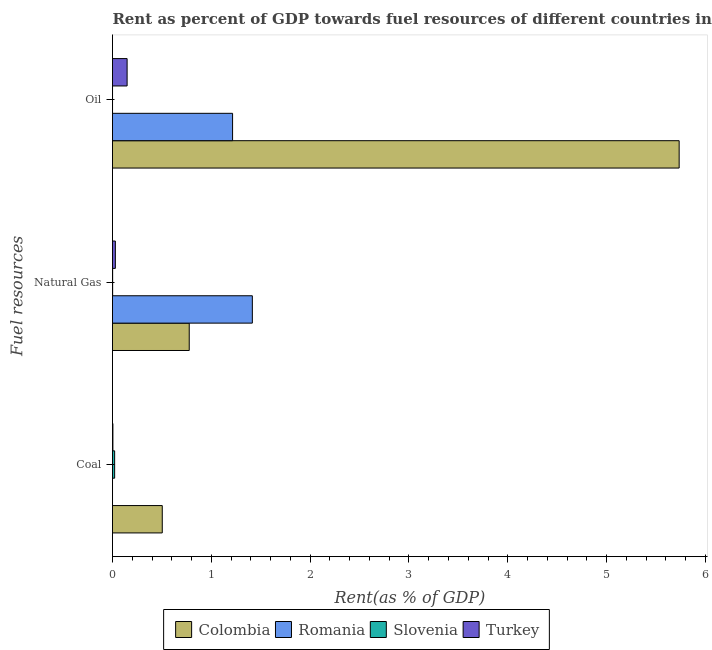How many different coloured bars are there?
Ensure brevity in your answer.  4. How many groups of bars are there?
Your answer should be compact. 3. Are the number of bars per tick equal to the number of legend labels?
Provide a succinct answer. Yes. What is the label of the 1st group of bars from the top?
Your answer should be very brief. Oil. What is the rent towards natural gas in Colombia?
Offer a terse response. 0.78. Across all countries, what is the maximum rent towards natural gas?
Your answer should be compact. 1.42. Across all countries, what is the minimum rent towards coal?
Give a very brief answer. 9.89979329873995e-5. In which country was the rent towards natural gas minimum?
Offer a very short reply. Slovenia. What is the total rent towards natural gas in the graph?
Make the answer very short. 2.22. What is the difference between the rent towards oil in Slovenia and that in Colombia?
Provide a short and direct response. -5.73. What is the difference between the rent towards oil in Slovenia and the rent towards natural gas in Romania?
Keep it short and to the point. -1.41. What is the average rent towards coal per country?
Provide a short and direct response. 0.13. What is the difference between the rent towards coal and rent towards oil in Colombia?
Your response must be concise. -5.23. What is the ratio of the rent towards oil in Turkey to that in Slovenia?
Keep it short and to the point. 640.72. What is the difference between the highest and the second highest rent towards oil?
Keep it short and to the point. 4.52. What is the difference between the highest and the lowest rent towards natural gas?
Provide a succinct answer. 1.41. In how many countries, is the rent towards coal greater than the average rent towards coal taken over all countries?
Your answer should be compact. 1. Is the sum of the rent towards coal in Turkey and Colombia greater than the maximum rent towards oil across all countries?
Provide a succinct answer. No. What does the 4th bar from the top in Coal represents?
Provide a succinct answer. Colombia. How many bars are there?
Offer a terse response. 12. How many countries are there in the graph?
Provide a short and direct response. 4. Are the values on the major ticks of X-axis written in scientific E-notation?
Provide a short and direct response. No. Where does the legend appear in the graph?
Your answer should be very brief. Bottom center. How are the legend labels stacked?
Provide a succinct answer. Horizontal. What is the title of the graph?
Make the answer very short. Rent as percent of GDP towards fuel resources of different countries in 2007. Does "St. Kitts and Nevis" appear as one of the legend labels in the graph?
Provide a short and direct response. No. What is the label or title of the X-axis?
Offer a very short reply. Rent(as % of GDP). What is the label or title of the Y-axis?
Offer a very short reply. Fuel resources. What is the Rent(as % of GDP) in Colombia in Coal?
Make the answer very short. 0.5. What is the Rent(as % of GDP) in Romania in Coal?
Your answer should be very brief. 9.89979329873995e-5. What is the Rent(as % of GDP) in Slovenia in Coal?
Offer a very short reply. 0.02. What is the Rent(as % of GDP) of Turkey in Coal?
Your answer should be compact. 0. What is the Rent(as % of GDP) of Colombia in Natural Gas?
Your response must be concise. 0.78. What is the Rent(as % of GDP) of Romania in Natural Gas?
Keep it short and to the point. 1.42. What is the Rent(as % of GDP) of Slovenia in Natural Gas?
Provide a succinct answer. 0. What is the Rent(as % of GDP) in Turkey in Natural Gas?
Offer a very short reply. 0.03. What is the Rent(as % of GDP) in Colombia in Oil?
Provide a succinct answer. 5.73. What is the Rent(as % of GDP) of Romania in Oil?
Give a very brief answer. 1.22. What is the Rent(as % of GDP) in Slovenia in Oil?
Offer a very short reply. 0. What is the Rent(as % of GDP) in Turkey in Oil?
Make the answer very short. 0.15. Across all Fuel resources, what is the maximum Rent(as % of GDP) in Colombia?
Provide a short and direct response. 5.73. Across all Fuel resources, what is the maximum Rent(as % of GDP) of Romania?
Give a very brief answer. 1.42. Across all Fuel resources, what is the maximum Rent(as % of GDP) in Slovenia?
Offer a terse response. 0.02. Across all Fuel resources, what is the maximum Rent(as % of GDP) in Turkey?
Provide a short and direct response. 0.15. Across all Fuel resources, what is the minimum Rent(as % of GDP) in Colombia?
Offer a terse response. 0.5. Across all Fuel resources, what is the minimum Rent(as % of GDP) of Romania?
Offer a very short reply. 9.89979329873995e-5. Across all Fuel resources, what is the minimum Rent(as % of GDP) of Slovenia?
Offer a very short reply. 0. Across all Fuel resources, what is the minimum Rent(as % of GDP) of Turkey?
Provide a short and direct response. 0. What is the total Rent(as % of GDP) in Colombia in the graph?
Your response must be concise. 7.01. What is the total Rent(as % of GDP) of Romania in the graph?
Provide a short and direct response. 2.63. What is the total Rent(as % of GDP) of Slovenia in the graph?
Offer a terse response. 0.02. What is the total Rent(as % of GDP) of Turkey in the graph?
Provide a succinct answer. 0.18. What is the difference between the Rent(as % of GDP) in Colombia in Coal and that in Natural Gas?
Make the answer very short. -0.27. What is the difference between the Rent(as % of GDP) of Romania in Coal and that in Natural Gas?
Your response must be concise. -1.42. What is the difference between the Rent(as % of GDP) in Slovenia in Coal and that in Natural Gas?
Your response must be concise. 0.02. What is the difference between the Rent(as % of GDP) of Turkey in Coal and that in Natural Gas?
Make the answer very short. -0.02. What is the difference between the Rent(as % of GDP) in Colombia in Coal and that in Oil?
Offer a terse response. -5.23. What is the difference between the Rent(as % of GDP) of Romania in Coal and that in Oil?
Your answer should be compact. -1.22. What is the difference between the Rent(as % of GDP) in Slovenia in Coal and that in Oil?
Ensure brevity in your answer.  0.02. What is the difference between the Rent(as % of GDP) in Turkey in Coal and that in Oil?
Ensure brevity in your answer.  -0.14. What is the difference between the Rent(as % of GDP) of Colombia in Natural Gas and that in Oil?
Give a very brief answer. -4.96. What is the difference between the Rent(as % of GDP) in Romania in Natural Gas and that in Oil?
Offer a terse response. 0.2. What is the difference between the Rent(as % of GDP) in Slovenia in Natural Gas and that in Oil?
Offer a terse response. 0. What is the difference between the Rent(as % of GDP) in Turkey in Natural Gas and that in Oil?
Provide a succinct answer. -0.12. What is the difference between the Rent(as % of GDP) in Colombia in Coal and the Rent(as % of GDP) in Romania in Natural Gas?
Provide a short and direct response. -0.91. What is the difference between the Rent(as % of GDP) in Colombia in Coal and the Rent(as % of GDP) in Slovenia in Natural Gas?
Your answer should be very brief. 0.5. What is the difference between the Rent(as % of GDP) of Colombia in Coal and the Rent(as % of GDP) of Turkey in Natural Gas?
Offer a very short reply. 0.47. What is the difference between the Rent(as % of GDP) of Romania in Coal and the Rent(as % of GDP) of Slovenia in Natural Gas?
Offer a very short reply. -0. What is the difference between the Rent(as % of GDP) in Romania in Coal and the Rent(as % of GDP) in Turkey in Natural Gas?
Make the answer very short. -0.03. What is the difference between the Rent(as % of GDP) in Slovenia in Coal and the Rent(as % of GDP) in Turkey in Natural Gas?
Your response must be concise. -0.01. What is the difference between the Rent(as % of GDP) of Colombia in Coal and the Rent(as % of GDP) of Romania in Oil?
Make the answer very short. -0.71. What is the difference between the Rent(as % of GDP) of Colombia in Coal and the Rent(as % of GDP) of Slovenia in Oil?
Your response must be concise. 0.5. What is the difference between the Rent(as % of GDP) of Colombia in Coal and the Rent(as % of GDP) of Turkey in Oil?
Give a very brief answer. 0.36. What is the difference between the Rent(as % of GDP) of Romania in Coal and the Rent(as % of GDP) of Slovenia in Oil?
Provide a succinct answer. -0. What is the difference between the Rent(as % of GDP) of Romania in Coal and the Rent(as % of GDP) of Turkey in Oil?
Your answer should be very brief. -0.15. What is the difference between the Rent(as % of GDP) in Slovenia in Coal and the Rent(as % of GDP) in Turkey in Oil?
Give a very brief answer. -0.13. What is the difference between the Rent(as % of GDP) in Colombia in Natural Gas and the Rent(as % of GDP) in Romania in Oil?
Provide a succinct answer. -0.44. What is the difference between the Rent(as % of GDP) in Colombia in Natural Gas and the Rent(as % of GDP) in Slovenia in Oil?
Offer a very short reply. 0.78. What is the difference between the Rent(as % of GDP) in Colombia in Natural Gas and the Rent(as % of GDP) in Turkey in Oil?
Offer a very short reply. 0.63. What is the difference between the Rent(as % of GDP) of Romania in Natural Gas and the Rent(as % of GDP) of Slovenia in Oil?
Ensure brevity in your answer.  1.41. What is the difference between the Rent(as % of GDP) in Romania in Natural Gas and the Rent(as % of GDP) in Turkey in Oil?
Keep it short and to the point. 1.27. What is the difference between the Rent(as % of GDP) of Slovenia in Natural Gas and the Rent(as % of GDP) of Turkey in Oil?
Your answer should be very brief. -0.15. What is the average Rent(as % of GDP) of Colombia per Fuel resources?
Offer a very short reply. 2.34. What is the average Rent(as % of GDP) of Romania per Fuel resources?
Ensure brevity in your answer.  0.88. What is the average Rent(as % of GDP) of Slovenia per Fuel resources?
Your answer should be very brief. 0.01. What is the average Rent(as % of GDP) in Turkey per Fuel resources?
Provide a short and direct response. 0.06. What is the difference between the Rent(as % of GDP) in Colombia and Rent(as % of GDP) in Romania in Coal?
Provide a short and direct response. 0.5. What is the difference between the Rent(as % of GDP) in Colombia and Rent(as % of GDP) in Slovenia in Coal?
Provide a short and direct response. 0.48. What is the difference between the Rent(as % of GDP) of Colombia and Rent(as % of GDP) of Turkey in Coal?
Offer a very short reply. 0.5. What is the difference between the Rent(as % of GDP) in Romania and Rent(as % of GDP) in Slovenia in Coal?
Offer a terse response. -0.02. What is the difference between the Rent(as % of GDP) in Romania and Rent(as % of GDP) in Turkey in Coal?
Offer a very short reply. -0. What is the difference between the Rent(as % of GDP) of Slovenia and Rent(as % of GDP) of Turkey in Coal?
Provide a succinct answer. 0.02. What is the difference between the Rent(as % of GDP) of Colombia and Rent(as % of GDP) of Romania in Natural Gas?
Your answer should be very brief. -0.64. What is the difference between the Rent(as % of GDP) of Colombia and Rent(as % of GDP) of Slovenia in Natural Gas?
Make the answer very short. 0.78. What is the difference between the Rent(as % of GDP) in Colombia and Rent(as % of GDP) in Turkey in Natural Gas?
Offer a very short reply. 0.75. What is the difference between the Rent(as % of GDP) of Romania and Rent(as % of GDP) of Slovenia in Natural Gas?
Give a very brief answer. 1.41. What is the difference between the Rent(as % of GDP) of Romania and Rent(as % of GDP) of Turkey in Natural Gas?
Your answer should be compact. 1.39. What is the difference between the Rent(as % of GDP) in Slovenia and Rent(as % of GDP) in Turkey in Natural Gas?
Make the answer very short. -0.03. What is the difference between the Rent(as % of GDP) of Colombia and Rent(as % of GDP) of Romania in Oil?
Keep it short and to the point. 4.52. What is the difference between the Rent(as % of GDP) in Colombia and Rent(as % of GDP) in Slovenia in Oil?
Ensure brevity in your answer.  5.73. What is the difference between the Rent(as % of GDP) of Colombia and Rent(as % of GDP) of Turkey in Oil?
Offer a very short reply. 5.59. What is the difference between the Rent(as % of GDP) of Romania and Rent(as % of GDP) of Slovenia in Oil?
Ensure brevity in your answer.  1.21. What is the difference between the Rent(as % of GDP) of Romania and Rent(as % of GDP) of Turkey in Oil?
Provide a short and direct response. 1.07. What is the difference between the Rent(as % of GDP) in Slovenia and Rent(as % of GDP) in Turkey in Oil?
Give a very brief answer. -0.15. What is the ratio of the Rent(as % of GDP) of Colombia in Coal to that in Natural Gas?
Give a very brief answer. 0.65. What is the ratio of the Rent(as % of GDP) of Slovenia in Coal to that in Natural Gas?
Give a very brief answer. 15.64. What is the ratio of the Rent(as % of GDP) of Turkey in Coal to that in Natural Gas?
Ensure brevity in your answer.  0.14. What is the ratio of the Rent(as % of GDP) in Colombia in Coal to that in Oil?
Your response must be concise. 0.09. What is the ratio of the Rent(as % of GDP) of Romania in Coal to that in Oil?
Make the answer very short. 0. What is the ratio of the Rent(as % of GDP) of Slovenia in Coal to that in Oil?
Offer a very short reply. 94.03. What is the ratio of the Rent(as % of GDP) of Turkey in Coal to that in Oil?
Offer a terse response. 0.03. What is the ratio of the Rent(as % of GDP) in Colombia in Natural Gas to that in Oil?
Provide a succinct answer. 0.14. What is the ratio of the Rent(as % of GDP) in Romania in Natural Gas to that in Oil?
Ensure brevity in your answer.  1.16. What is the ratio of the Rent(as % of GDP) of Slovenia in Natural Gas to that in Oil?
Your answer should be very brief. 6.01. What is the ratio of the Rent(as % of GDP) in Turkey in Natural Gas to that in Oil?
Provide a short and direct response. 0.2. What is the difference between the highest and the second highest Rent(as % of GDP) in Colombia?
Provide a succinct answer. 4.96. What is the difference between the highest and the second highest Rent(as % of GDP) of Romania?
Make the answer very short. 0.2. What is the difference between the highest and the second highest Rent(as % of GDP) of Slovenia?
Your answer should be compact. 0.02. What is the difference between the highest and the second highest Rent(as % of GDP) of Turkey?
Offer a terse response. 0.12. What is the difference between the highest and the lowest Rent(as % of GDP) in Colombia?
Your answer should be very brief. 5.23. What is the difference between the highest and the lowest Rent(as % of GDP) in Romania?
Offer a very short reply. 1.42. What is the difference between the highest and the lowest Rent(as % of GDP) in Slovenia?
Your answer should be compact. 0.02. What is the difference between the highest and the lowest Rent(as % of GDP) in Turkey?
Make the answer very short. 0.14. 